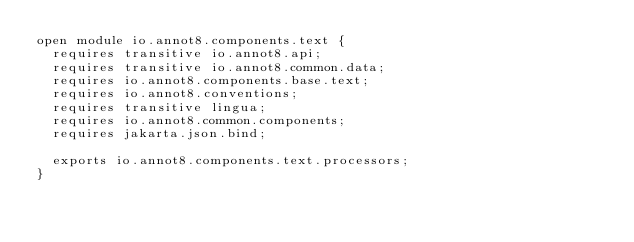<code> <loc_0><loc_0><loc_500><loc_500><_Java_>open module io.annot8.components.text {
  requires transitive io.annot8.api;
  requires transitive io.annot8.common.data;
  requires io.annot8.components.base.text;
  requires io.annot8.conventions;
  requires transitive lingua;
  requires io.annot8.common.components;
  requires jakarta.json.bind;

  exports io.annot8.components.text.processors;
}
</code> 